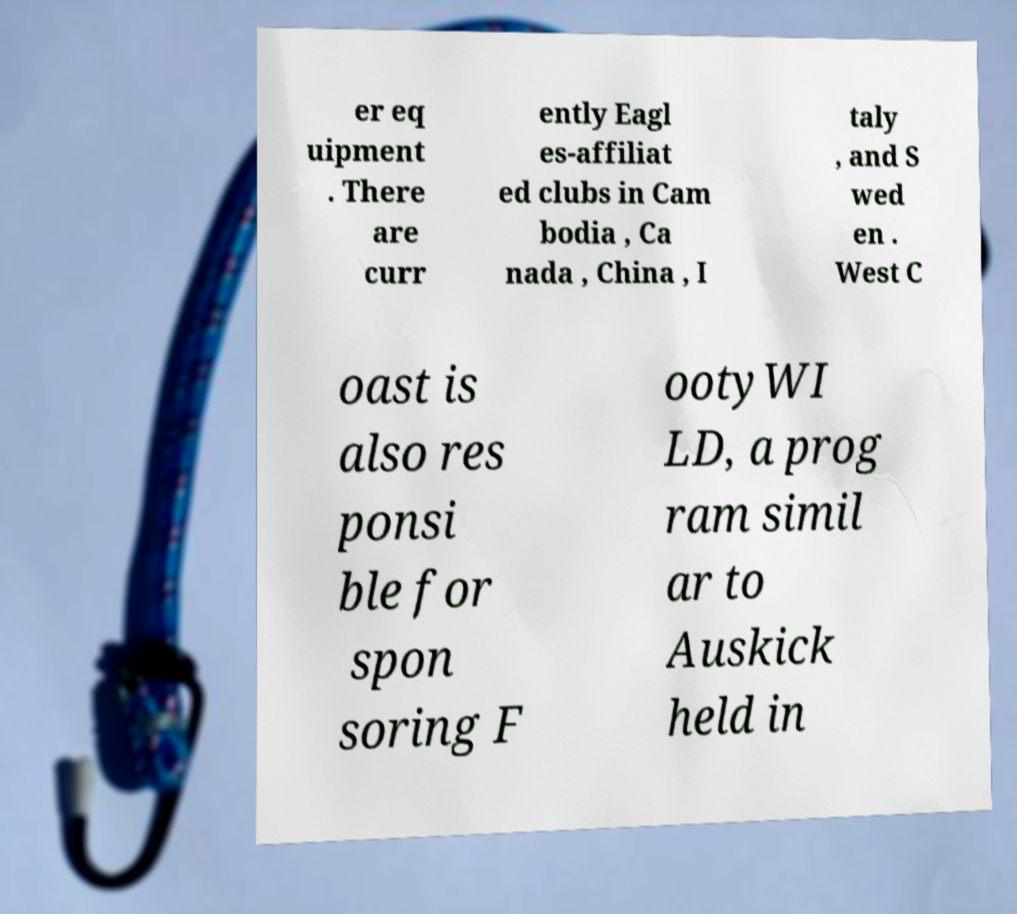For documentation purposes, I need the text within this image transcribed. Could you provide that? er eq uipment . There are curr ently Eagl es-affiliat ed clubs in Cam bodia , Ca nada , China , I taly , and S wed en . West C oast is also res ponsi ble for spon soring F ootyWI LD, a prog ram simil ar to Auskick held in 